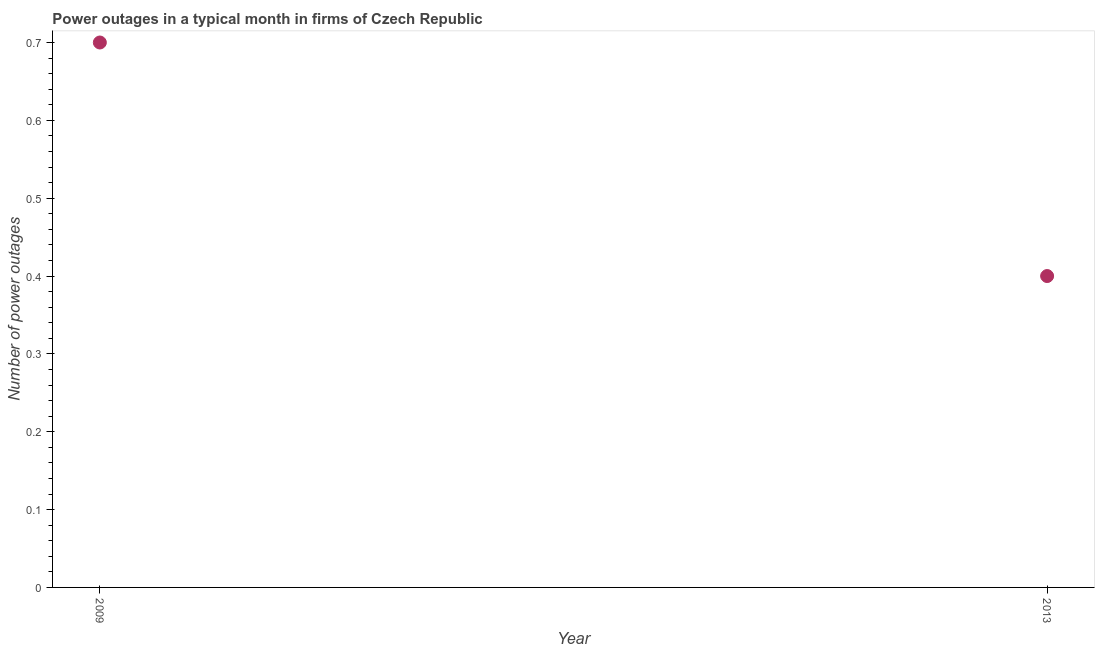What is the number of power outages in 2013?
Your response must be concise. 0.4. In which year was the number of power outages maximum?
Your answer should be very brief. 2009. What is the sum of the number of power outages?
Keep it short and to the point. 1.1. What is the difference between the number of power outages in 2009 and 2013?
Ensure brevity in your answer.  0.3. What is the average number of power outages per year?
Your answer should be compact. 0.55. What is the median number of power outages?
Provide a succinct answer. 0.55. Do a majority of the years between 2009 and 2013 (inclusive) have number of power outages greater than 0.46 ?
Your answer should be very brief. No. What is the ratio of the number of power outages in 2009 to that in 2013?
Make the answer very short. 1.75. Is the number of power outages in 2009 less than that in 2013?
Offer a very short reply. No. How many years are there in the graph?
Keep it short and to the point. 2. What is the difference between two consecutive major ticks on the Y-axis?
Offer a very short reply. 0.1. Are the values on the major ticks of Y-axis written in scientific E-notation?
Your answer should be compact. No. Does the graph contain any zero values?
Your response must be concise. No. Does the graph contain grids?
Provide a short and direct response. No. What is the title of the graph?
Make the answer very short. Power outages in a typical month in firms of Czech Republic. What is the label or title of the Y-axis?
Ensure brevity in your answer.  Number of power outages. What is the Number of power outages in 2009?
Make the answer very short. 0.7. What is the Number of power outages in 2013?
Provide a succinct answer. 0.4. 